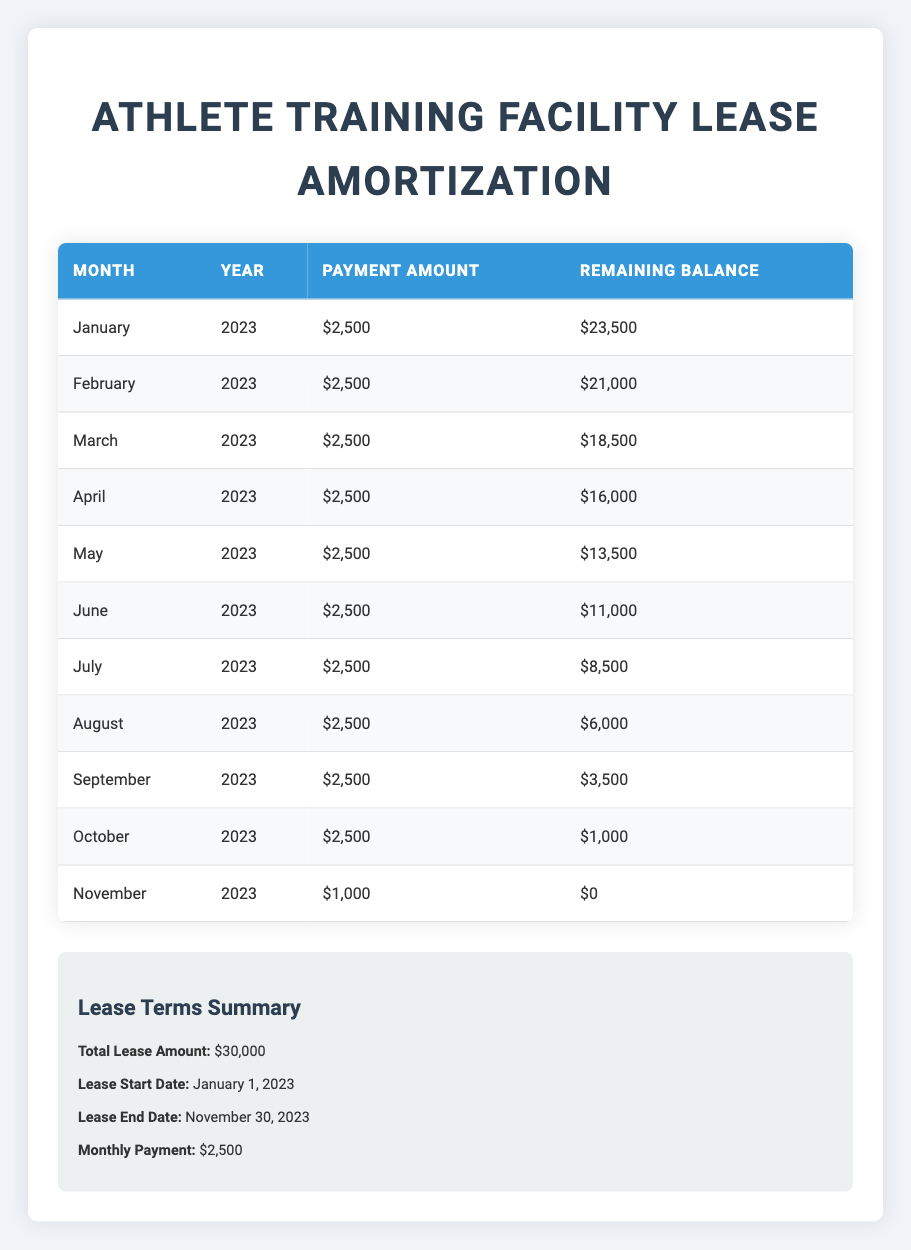What is the total lease amount for the Athlete Training Facility? The total lease amount is stated in the lease terms summary as $30,000.
Answer: $30,000 How much was the remaining balance after the payment in June 2023? The table shows that the remaining balance after the payment in June 2023 was $11,000.
Answer: $11,000 How many months did it take to fully pay off the lease? The lease payments are shown from January to November 2023, totaling 11 months, indicating it took 11 months to fully pay off the lease.
Answer: 11 months What was the payment amount for November 2023? The table indicates that the payment amount for November 2023 was $1,000.
Answer: $1,000 Was the payment amount consistent for most of the months? Yes, the payment amount was consistently $2,500 for the first ten months; only November had a different amount of $1,000.
Answer: Yes What is the total amount paid from January to October 2023? The payments from January to October 2023 total $2,500 for each month for 10 months, which is \(2,500 \times 10 = 25,000\).
Answer: $25,000 What was the remaining balance at the end of September 2023? According to the table, the remaining balance at the end of September 2023 was $3,500.
Answer: $3,500 How much did the remaining balance decrease from May to June 2023? The remaining balance was $13,500 at the end of May and $11,000 at the end of June. The decrease is \(13,500 - 11,000 = 2,500\).
Answer: $2,500 Which month had the smallest payment amount and what was it? The smallest payment amount was in November 2023, where the payment was $1,000, as stated in the table.
Answer: $1,000 